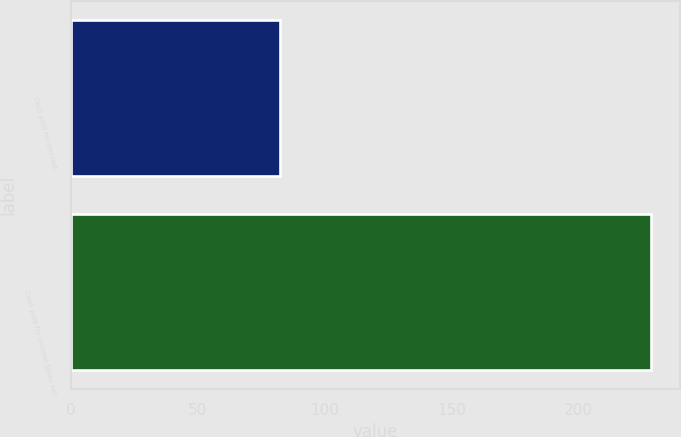Convert chart to OTSL. <chart><loc_0><loc_0><loc_500><loc_500><bar_chart><fcel>Cash paid for interest<fcel>Cash paid for income taxes net<nl><fcel>82.3<fcel>228.4<nl></chart> 